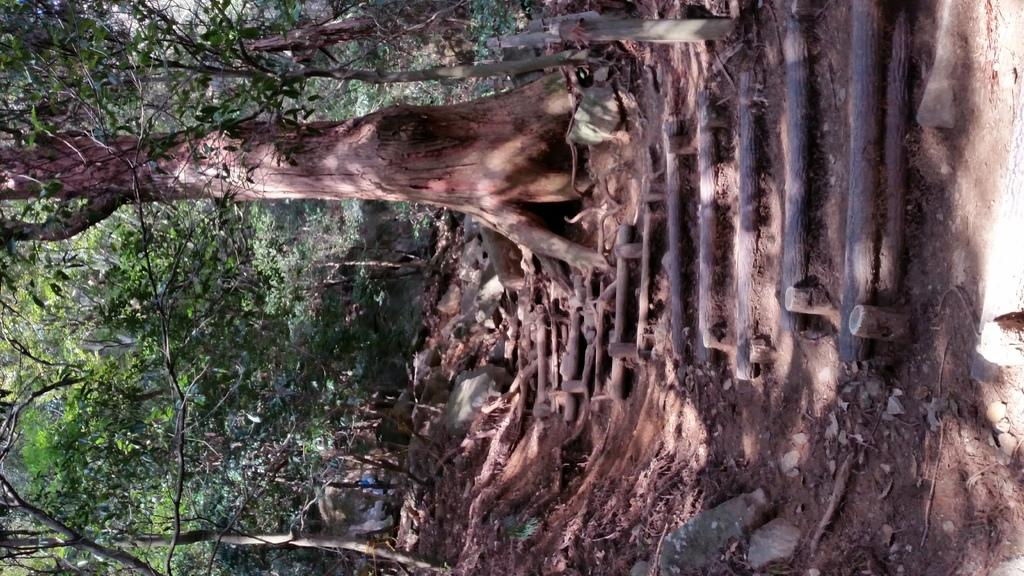What type of vegetation can be seen in the image? There are trees in the image. What objects are arranged on a surface in the image? Wooden sticks are arranged on a surface in the image. What type of skate is being used by the spy in the image? There is no skate or spy present in the image; it only features trees and wooden sticks arranged on a surface. 